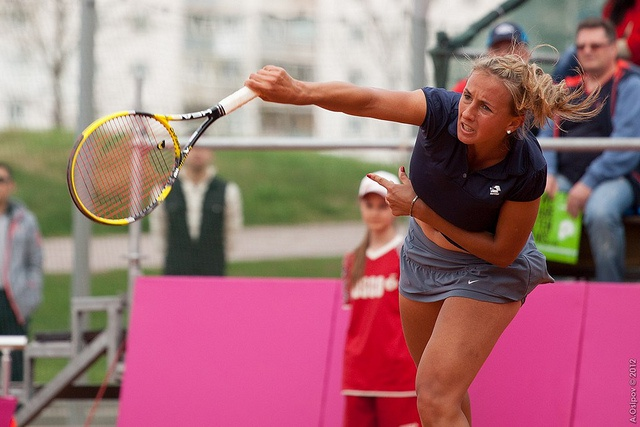Describe the objects in this image and their specific colors. I can see people in lightgray, black, maroon, and brown tones, people in lightgray, black, gray, and brown tones, people in lightgray, brown, and lightpink tones, tennis racket in lightgray, gray, tan, and darkgray tones, and people in lightgray, black, darkgray, and gray tones in this image. 